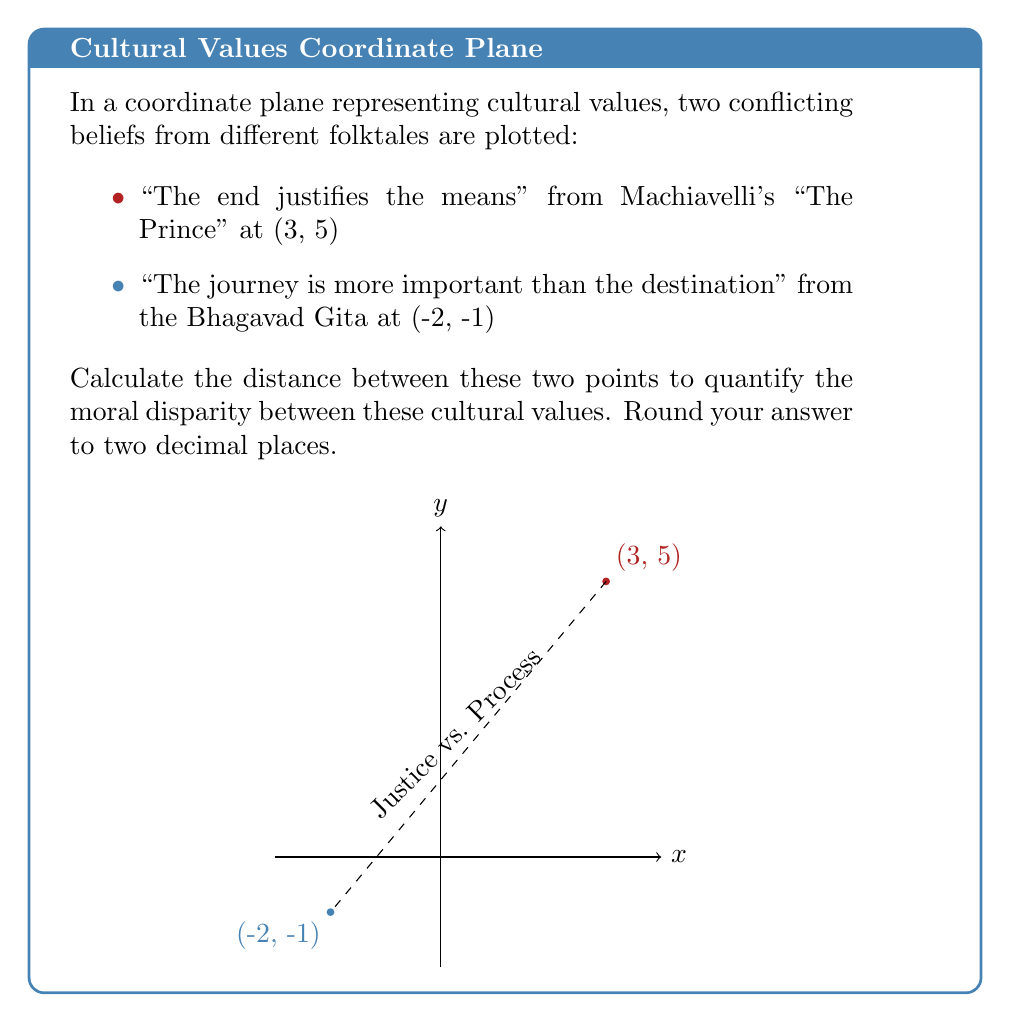Can you solve this math problem? To find the distance between two points in a coordinate plane, we use the distance formula:

$$d = \sqrt{(x_2 - x_1)^2 + (y_2 - y_1)^2}$$

Where $(x_1, y_1)$ is the first point and $(x_2, y_2)$ is the second point.

In this case:
$(x_1, y_1) = (3, 5)$ representing "The end justifies the means"
$(x_2, y_2) = (-2, -1)$ representing "The journey is more important than the destination"

Let's substitute these values into the formula:

$$\begin{align}
d &= \sqrt{(-2 - 3)^2 + (-1 - 5)^2} \\
&= \sqrt{(-5)^2 + (-6)^2} \\
&= \sqrt{25 + 36} \\
&= \sqrt{61} \\
&\approx 7.81
\end{align}$$

Rounding to two decimal places, we get 7.81.

This distance represents the moral disparity between the two cultural values, with a larger distance indicating a greater difference in philosophical standpoints.
Answer: $7.81$ 